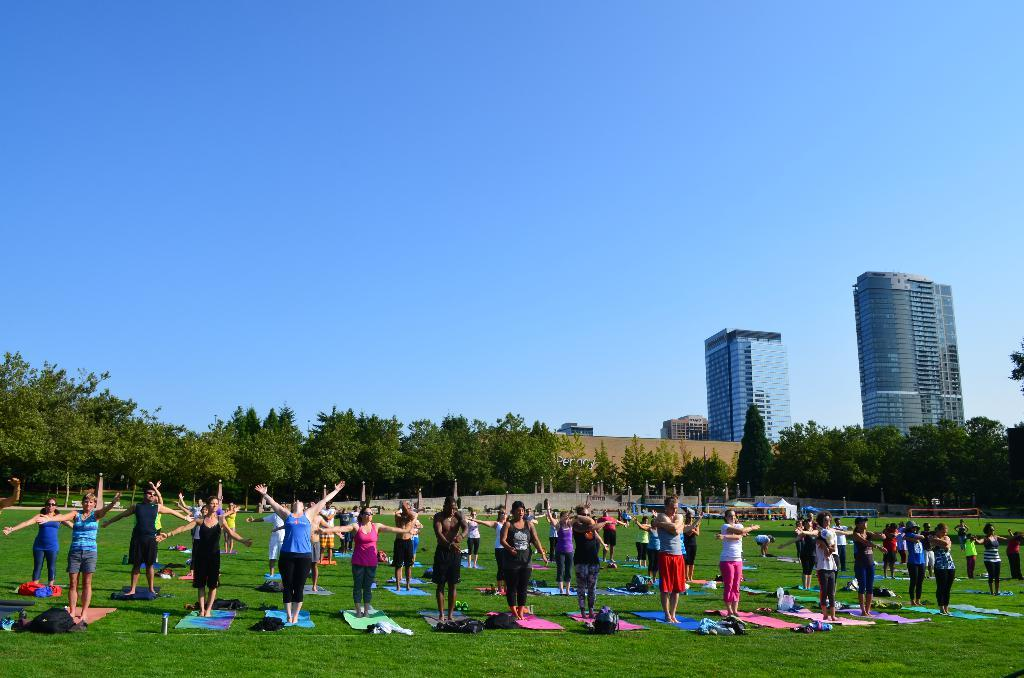How many people are in the group visible in the image? There is a group of people in the image, but the exact number cannot be determined from the provided facts. What is the setting of the image? The group of people is standing on what appears to be Mars. What can be seen in the background of the image? There are trees, buildings, and the sky visible in the background of the image. What is present on the ground in the image? There is grass and other objects on the ground in the image. What type of pancake is being served to the group of people in the image? There is no pancake present in the image; the group of people is standing on what appears to be Mars. 